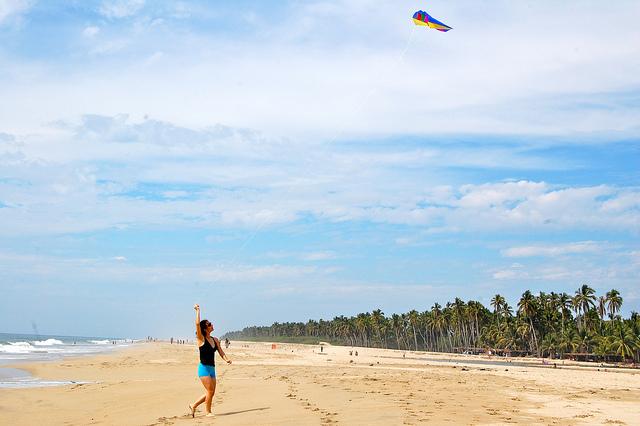Is it summer?
Be succinct. Yes. Is it a hot day in this picture?
Quick response, please. Yes. Are there more than one person in the scene?
Write a very short answer. Yes. What is the lady flying?
Short answer required. Kite. What color are the ladies shorts?
Give a very brief answer. Blue. Would you call this scene lush with vegetation?
Give a very brief answer. Yes. Who is in the background?
Quick response, please. People. Is this a tourist area?
Be succinct. Yes. 